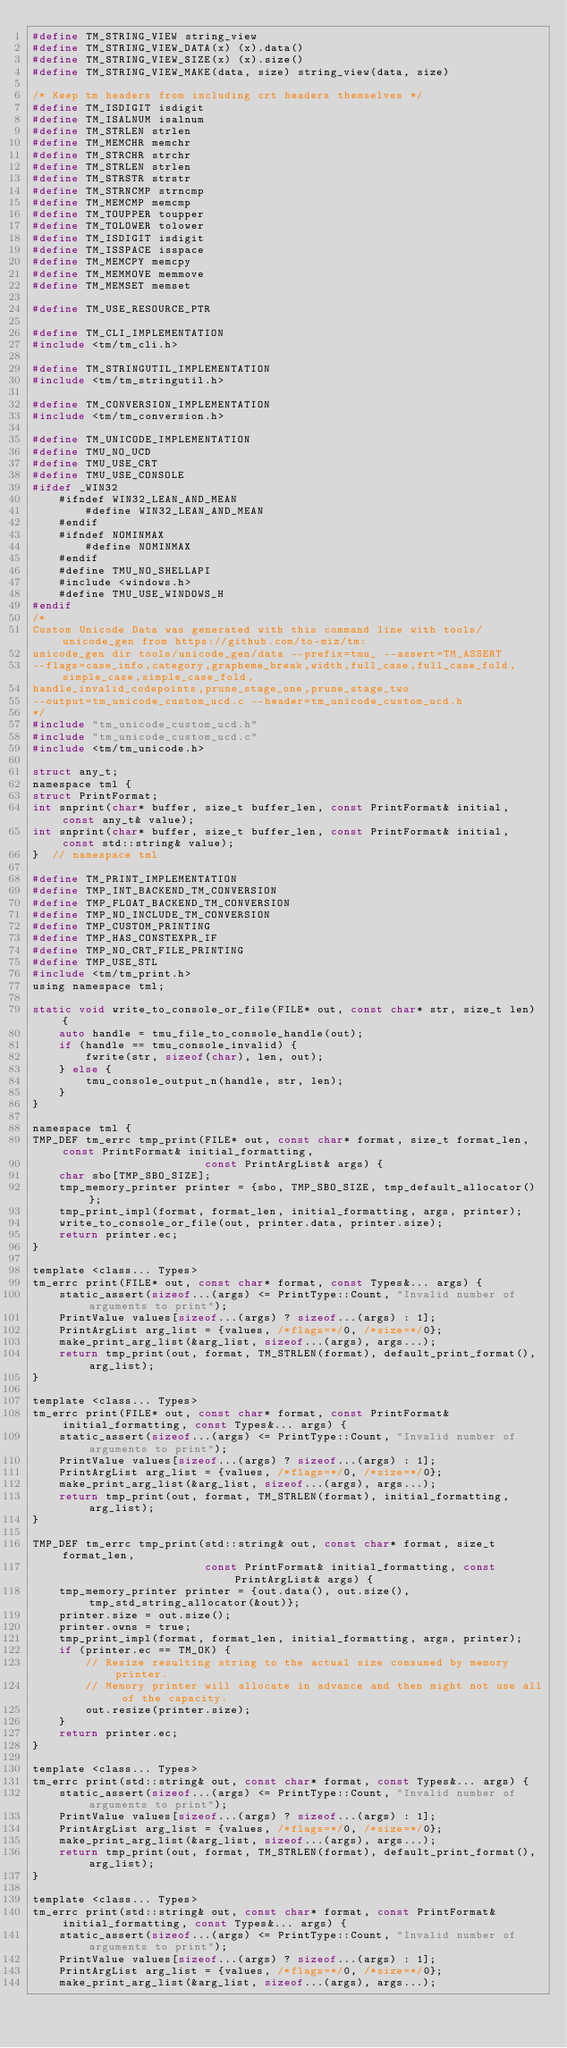<code> <loc_0><loc_0><loc_500><loc_500><_C_>#define TM_STRING_VIEW string_view
#define TM_STRING_VIEW_DATA(x) (x).data()
#define TM_STRING_VIEW_SIZE(x) (x).size()
#define TM_STRING_VIEW_MAKE(data, size) string_view(data, size)

/* Keep tm headers from including crt headers themselves */
#define TM_ISDIGIT isdigit
#define TM_ISALNUM isalnum
#define TM_STRLEN strlen
#define TM_MEMCHR memchr
#define TM_STRCHR strchr
#define TM_STRLEN strlen
#define TM_STRSTR strstr
#define TM_STRNCMP strncmp
#define TM_MEMCMP memcmp
#define TM_TOUPPER toupper
#define TM_TOLOWER tolower
#define TM_ISDIGIT isdigit
#define TM_ISSPACE isspace
#define TM_MEMCPY memcpy
#define TM_MEMMOVE memmove
#define TM_MEMSET memset

#define TM_USE_RESOURCE_PTR

#define TM_CLI_IMPLEMENTATION
#include <tm/tm_cli.h>

#define TM_STRINGUTIL_IMPLEMENTATION
#include <tm/tm_stringutil.h>

#define TM_CONVERSION_IMPLEMENTATION
#include <tm/tm_conversion.h>

#define TM_UNICODE_IMPLEMENTATION
#define TMU_NO_UCD
#define TMU_USE_CRT
#define TMU_USE_CONSOLE
#ifdef _WIN32
    #ifndef WIN32_LEAN_AND_MEAN
        #define WIN32_LEAN_AND_MEAN
    #endif
    #ifndef NOMINMAX
        #define NOMINMAX
    #endif
    #define TMU_NO_SHELLAPI
    #include <windows.h>
    #define TMU_USE_WINDOWS_H
#endif
/*
Custom Unicode Data was generated with this command line with tools/unicode_gen from https://github.com/to-miz/tm:
unicode_gen dir tools/unicode_gen/data --prefix=tmu_ --assert=TM_ASSERT
--flags=case_info,category,grapheme_break,width,full_case,full_case_fold,simple_case,simple_case_fold,
handle_invalid_codepoints,prune_stage_one,prune_stage_two
--output=tm_unicode_custom_ucd.c --header=tm_unicode_custom_ucd.h
*/
#include "tm_unicode_custom_ucd.h"
#include "tm_unicode_custom_ucd.c"
#include <tm/tm_unicode.h>

struct any_t;
namespace tml {
struct PrintFormat;
int snprint(char* buffer, size_t buffer_len, const PrintFormat& initial, const any_t& value);
int snprint(char* buffer, size_t buffer_len, const PrintFormat& initial, const std::string& value);
}  // namespace tml

#define TM_PRINT_IMPLEMENTATION
#define TMP_INT_BACKEND_TM_CONVERSION
#define TMP_FLOAT_BACKEND_TM_CONVERSION
#define TMP_NO_INCLUDE_TM_CONVERSION
#define TMP_CUSTOM_PRINTING
#define TMP_HAS_CONSTEXPR_IF
#define TMP_NO_CRT_FILE_PRINTING
#define TMP_USE_STL
#include <tm/tm_print.h>
using namespace tml;

static void write_to_console_or_file(FILE* out, const char* str, size_t len) {
    auto handle = tmu_file_to_console_handle(out);
    if (handle == tmu_console_invalid) {
        fwrite(str, sizeof(char), len, out);
    } else {
        tmu_console_output_n(handle, str, len);
    }
}

namespace tml {
TMP_DEF tm_errc tmp_print(FILE* out, const char* format, size_t format_len, const PrintFormat& initial_formatting,
                          const PrintArgList& args) {
    char sbo[TMP_SBO_SIZE];
    tmp_memory_printer printer = {sbo, TMP_SBO_SIZE, tmp_default_allocator()};
    tmp_print_impl(format, format_len, initial_formatting, args, printer);
    write_to_console_or_file(out, printer.data, printer.size);
    return printer.ec;
}

template <class... Types>
tm_errc print(FILE* out, const char* format, const Types&... args) {
    static_assert(sizeof...(args) <= PrintType::Count, "Invalid number of arguments to print");
    PrintValue values[sizeof...(args) ? sizeof...(args) : 1];
    PrintArgList arg_list = {values, /*flags=*/0, /*size=*/0};
    make_print_arg_list(&arg_list, sizeof...(args), args...);
    return tmp_print(out, format, TM_STRLEN(format), default_print_format(), arg_list);
}

template <class... Types>
tm_errc print(FILE* out, const char* format, const PrintFormat& initial_formatting, const Types&... args) {
    static_assert(sizeof...(args) <= PrintType::Count, "Invalid number of arguments to print");
    PrintValue values[sizeof...(args) ? sizeof...(args) : 1];
    PrintArgList arg_list = {values, /*flags=*/0, /*size=*/0};
    make_print_arg_list(&arg_list, sizeof...(args), args...);
    return tmp_print(out, format, TM_STRLEN(format), initial_formatting, arg_list);
}

TMP_DEF tm_errc tmp_print(std::string& out, const char* format, size_t format_len,
                          const PrintFormat& initial_formatting, const PrintArgList& args) {
    tmp_memory_printer printer = {out.data(), out.size(), tmp_std_string_allocator(&out)};
    printer.size = out.size();
    printer.owns = true;
    tmp_print_impl(format, format_len, initial_formatting, args, printer);
    if (printer.ec == TM_OK) {
        // Resize resulting string to the actual size consumed by memory printer.
        // Memory printer will allocate in advance and then might not use all of the capacity.
        out.resize(printer.size);
    }
    return printer.ec;
}

template <class... Types>
tm_errc print(std::string& out, const char* format, const Types&... args) {
    static_assert(sizeof...(args) <= PrintType::Count, "Invalid number of arguments to print");
    PrintValue values[sizeof...(args) ? sizeof...(args) : 1];
    PrintArgList arg_list = {values, /*flags=*/0, /*size=*/0};
    make_print_arg_list(&arg_list, sizeof...(args), args...);
    return tmp_print(out, format, TM_STRLEN(format), default_print_format(), arg_list);
}

template <class... Types>
tm_errc print(std::string& out, const char* format, const PrintFormat& initial_formatting, const Types&... args) {
    static_assert(sizeof...(args) <= PrintType::Count, "Invalid number of arguments to print");
    PrintValue values[sizeof...(args) ? sizeof...(args) : 1];
    PrintArgList arg_list = {values, /*flags=*/0, /*size=*/0};
    make_print_arg_list(&arg_list, sizeof...(args), args...);</code> 